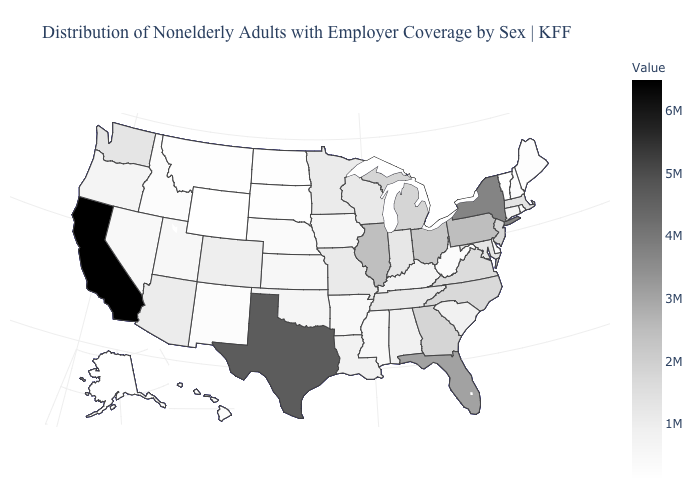Which states hav the highest value in the South?
Keep it brief. Texas. Among the states that border Montana , which have the highest value?
Keep it brief. Idaho. Does Virginia have a lower value than Louisiana?
Answer briefly. No. Does Oregon have the lowest value in the West?
Keep it brief. No. Among the states that border Kentucky , does Ohio have the highest value?
Answer briefly. No. Does Ohio have the lowest value in the MidWest?
Give a very brief answer. No. 